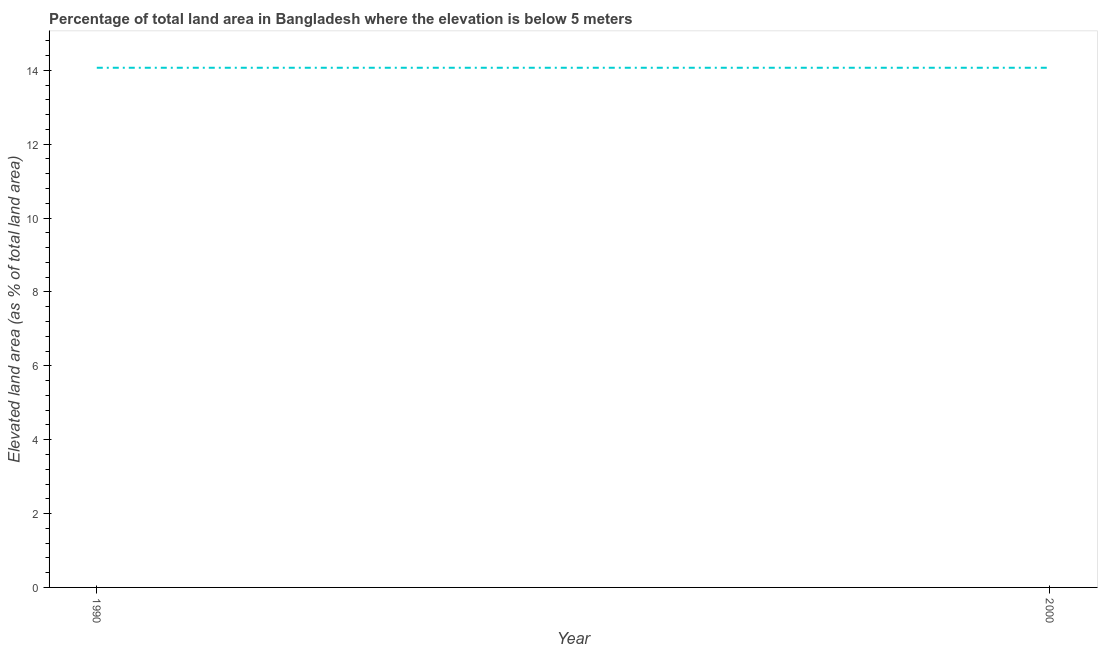What is the total elevated land area in 1990?
Your answer should be very brief. 14.07. Across all years, what is the maximum total elevated land area?
Make the answer very short. 14.07. Across all years, what is the minimum total elevated land area?
Provide a succinct answer. 14.07. In which year was the total elevated land area minimum?
Give a very brief answer. 1990. What is the sum of the total elevated land area?
Keep it short and to the point. 28.14. What is the difference between the total elevated land area in 1990 and 2000?
Your response must be concise. 0. What is the average total elevated land area per year?
Provide a succinct answer. 14.07. What is the median total elevated land area?
Give a very brief answer. 14.07. What is the ratio of the total elevated land area in 1990 to that in 2000?
Provide a short and direct response. 1. Is the total elevated land area in 1990 less than that in 2000?
Your response must be concise. No. What is the difference between two consecutive major ticks on the Y-axis?
Give a very brief answer. 2. Are the values on the major ticks of Y-axis written in scientific E-notation?
Give a very brief answer. No. What is the title of the graph?
Offer a very short reply. Percentage of total land area in Bangladesh where the elevation is below 5 meters. What is the label or title of the Y-axis?
Ensure brevity in your answer.  Elevated land area (as % of total land area). What is the Elevated land area (as % of total land area) of 1990?
Your answer should be compact. 14.07. What is the Elevated land area (as % of total land area) of 2000?
Offer a very short reply. 14.07. What is the difference between the Elevated land area (as % of total land area) in 1990 and 2000?
Offer a terse response. 0. 